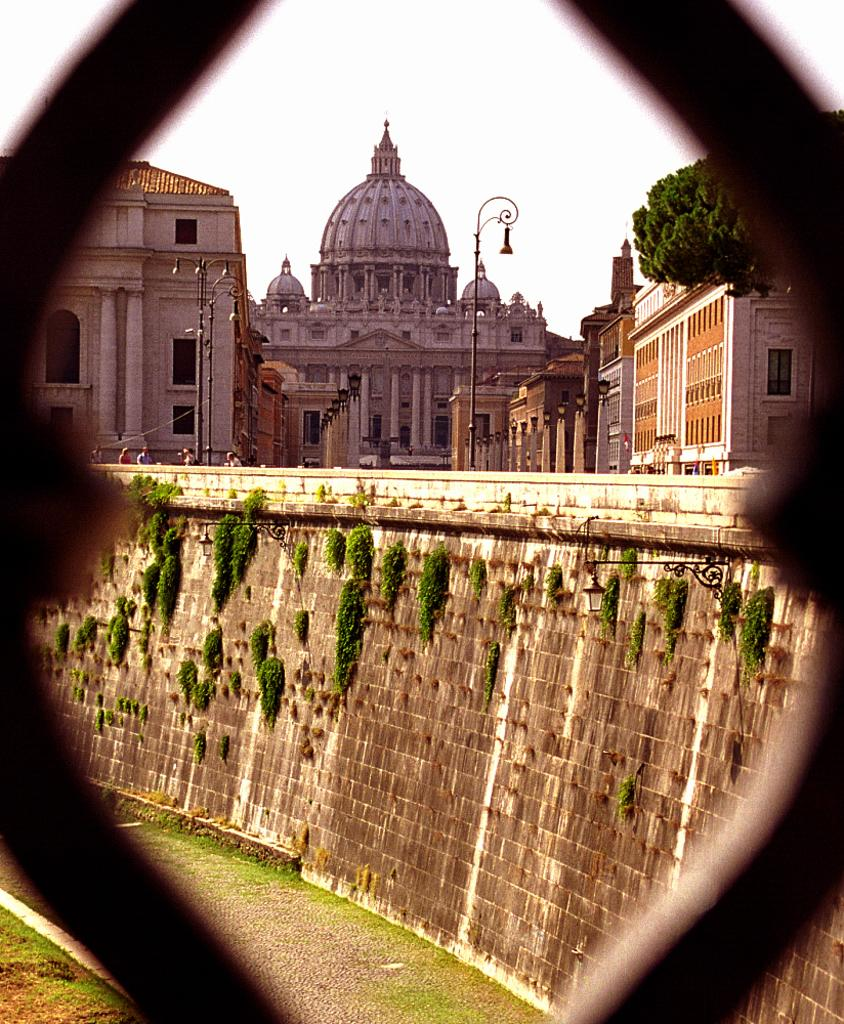What type of structures can be seen in the image? There are buildings in the image. What natural element is present in the image? There is a tree in the image. What type of lighting is visible in the image? There is a street lamp in the image. What is visible in the background of the image? The sky is visible in the image. What type of ticket is being sold at the building in the image? There is no indication of a ticket or any type of sale in the image. The image only shows buildings, a tree, a street lamp, and the sky. 